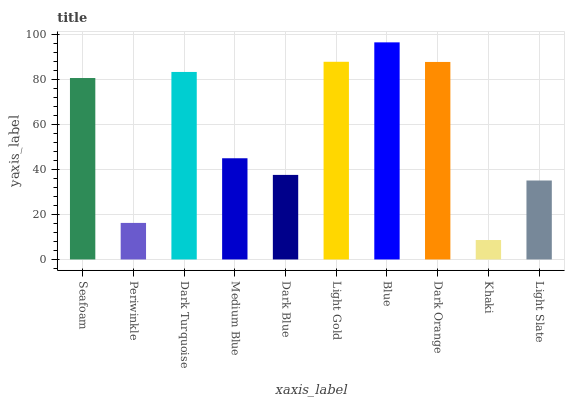Is Khaki the minimum?
Answer yes or no. Yes. Is Blue the maximum?
Answer yes or no. Yes. Is Periwinkle the minimum?
Answer yes or no. No. Is Periwinkle the maximum?
Answer yes or no. No. Is Seafoam greater than Periwinkle?
Answer yes or no. Yes. Is Periwinkle less than Seafoam?
Answer yes or no. Yes. Is Periwinkle greater than Seafoam?
Answer yes or no. No. Is Seafoam less than Periwinkle?
Answer yes or no. No. Is Seafoam the high median?
Answer yes or no. Yes. Is Medium Blue the low median?
Answer yes or no. Yes. Is Blue the high median?
Answer yes or no. No. Is Khaki the low median?
Answer yes or no. No. 